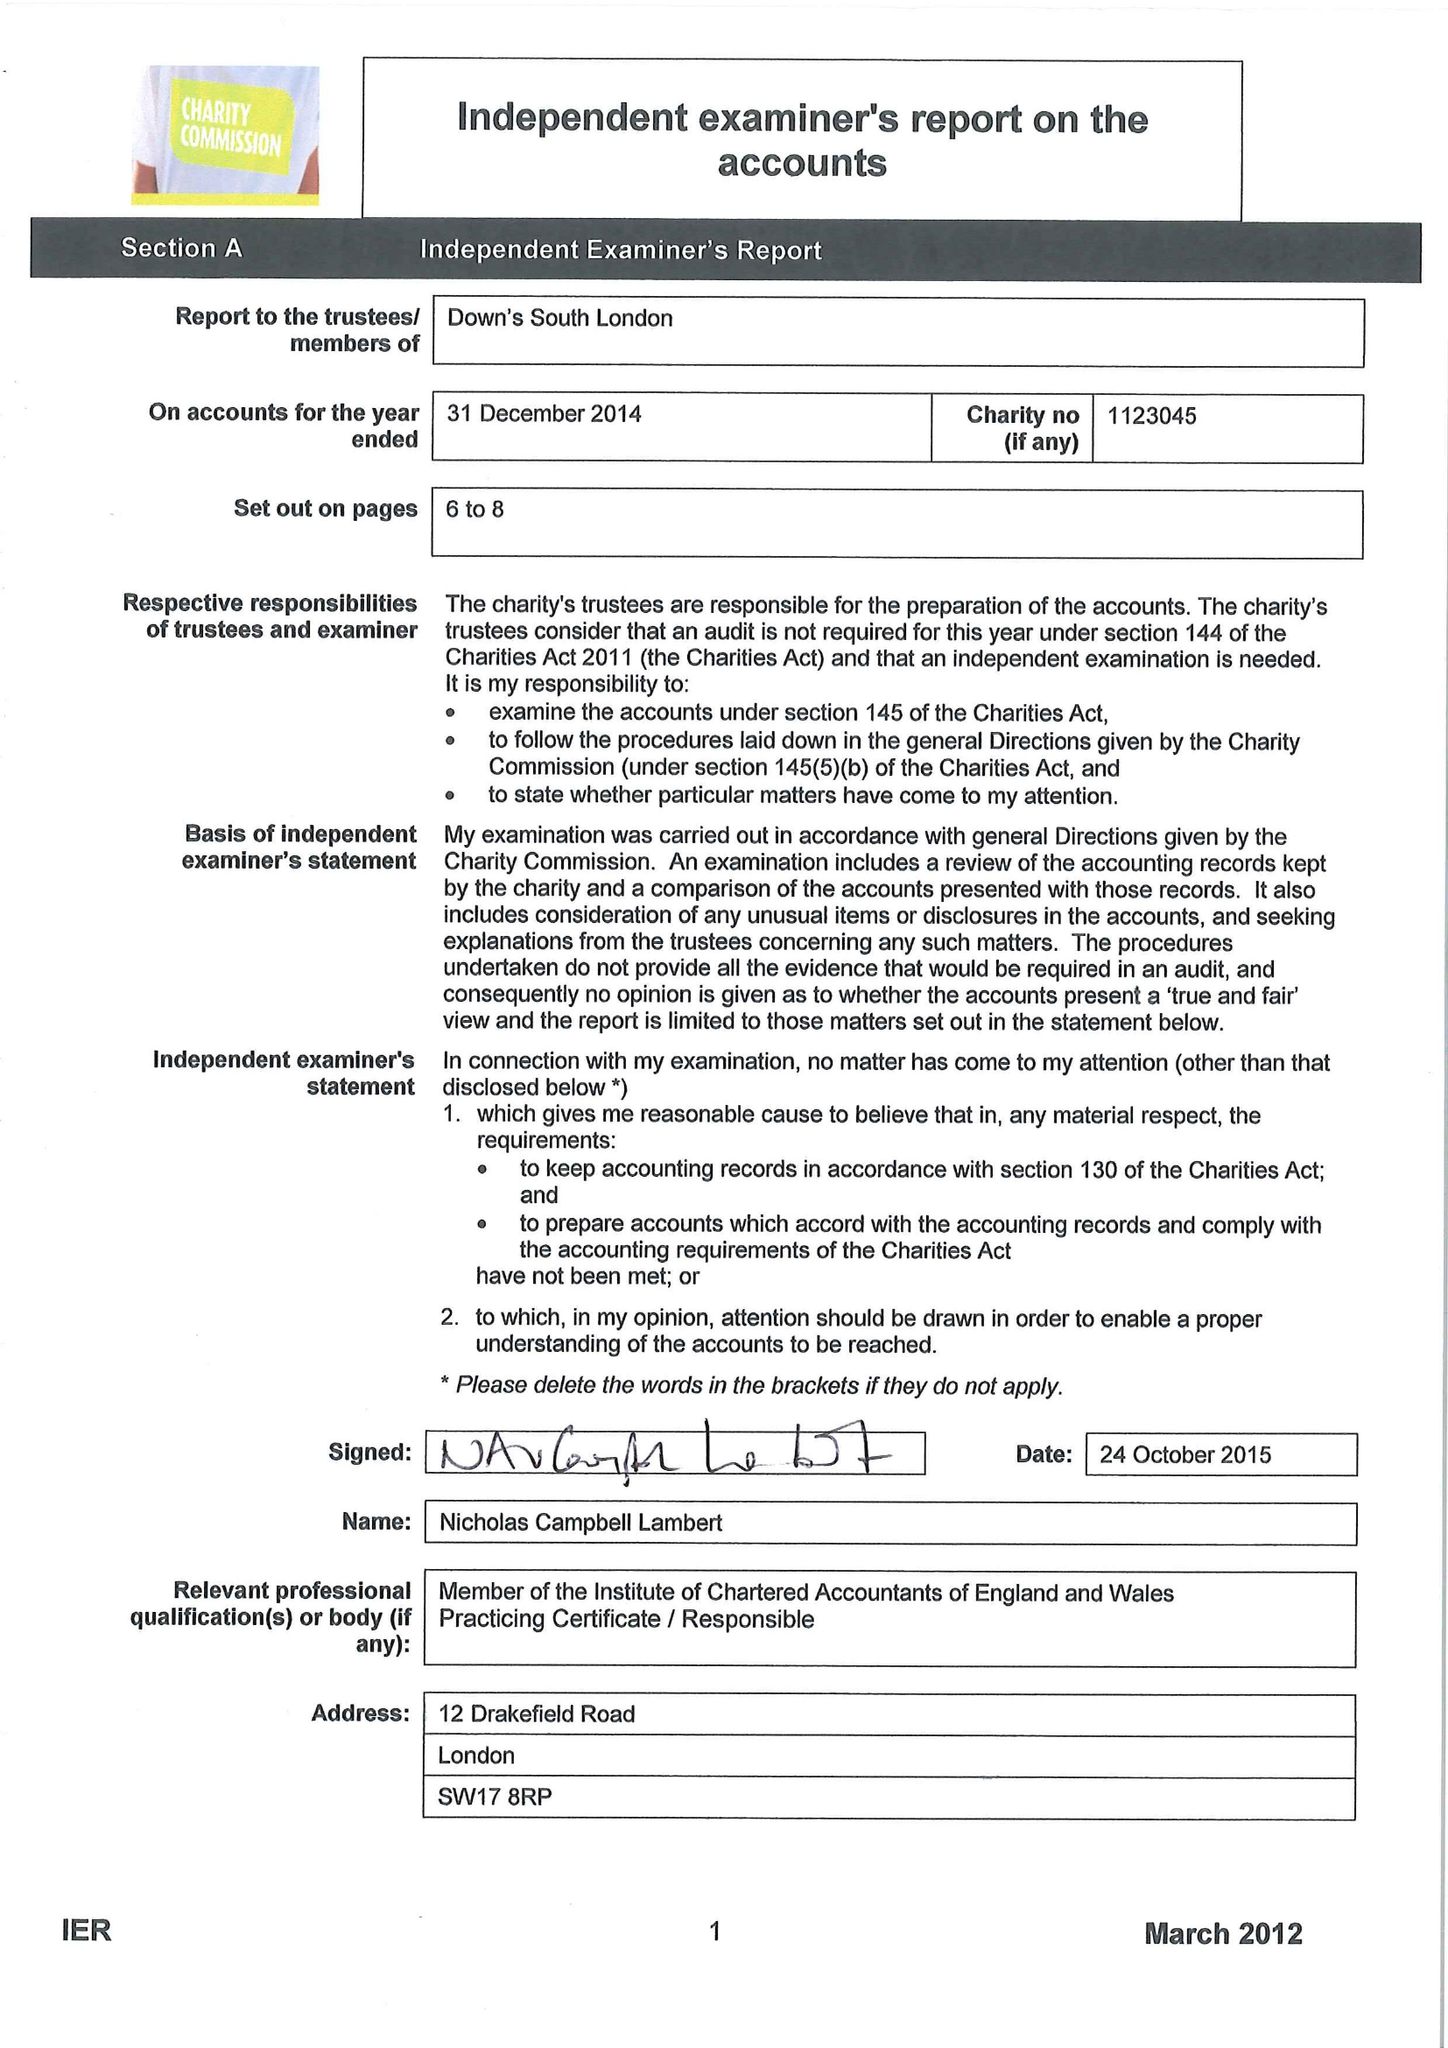What is the value for the charity_number?
Answer the question using a single word or phrase. 1123045 